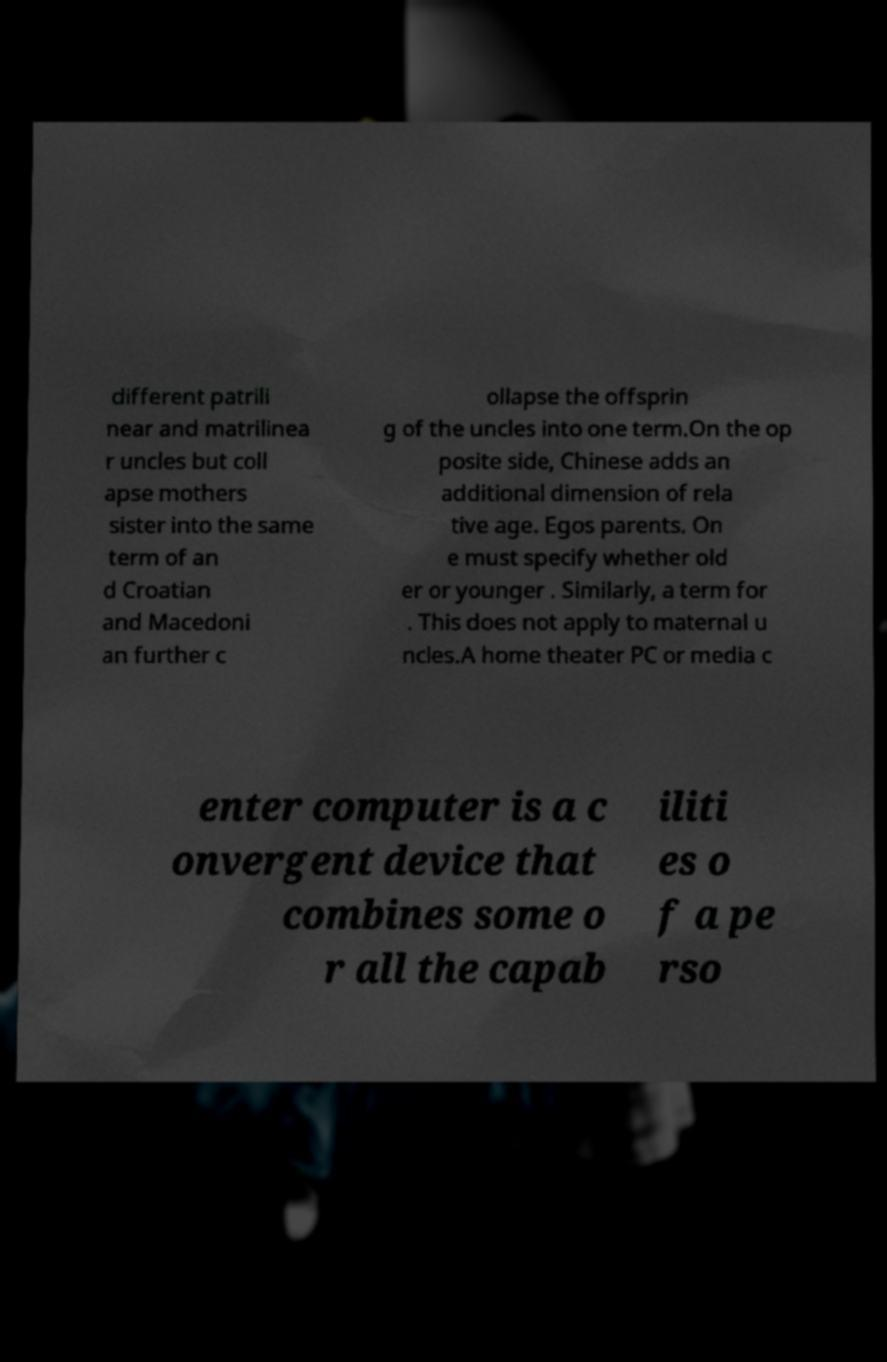Can you read and provide the text displayed in the image?This photo seems to have some interesting text. Can you extract and type it out for me? different patrili near and matrilinea r uncles but coll apse mothers sister into the same term of an d Croatian and Macedoni an further c ollapse the offsprin g of the uncles into one term.On the op posite side, Chinese adds an additional dimension of rela tive age. Egos parents. On e must specify whether old er or younger . Similarly, a term for . This does not apply to maternal u ncles.A home theater PC or media c enter computer is a c onvergent device that combines some o r all the capab iliti es o f a pe rso 